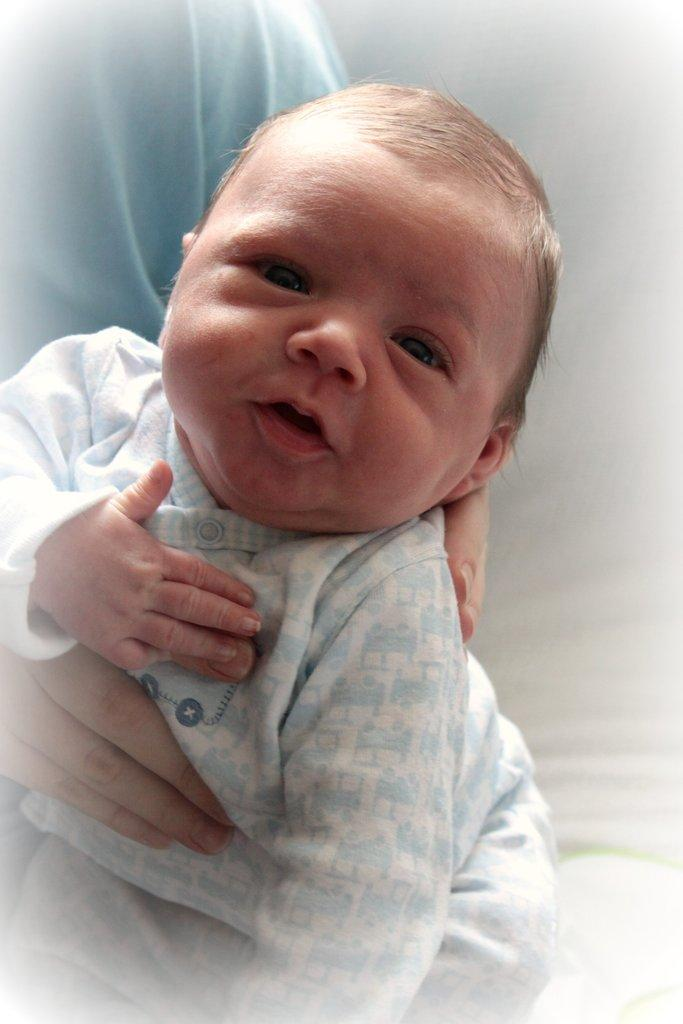Who is present in the image? There is a person in the image. What is the person doing in the image? The person is holding a child. Is the child also visible in the image? Yes, the child is in the image. What are the person and the child wearing? Both the person and the child are wearing clothes. What type of nail is being used to hold the cakes together in the image? There are no cakes or nails present in the image. 